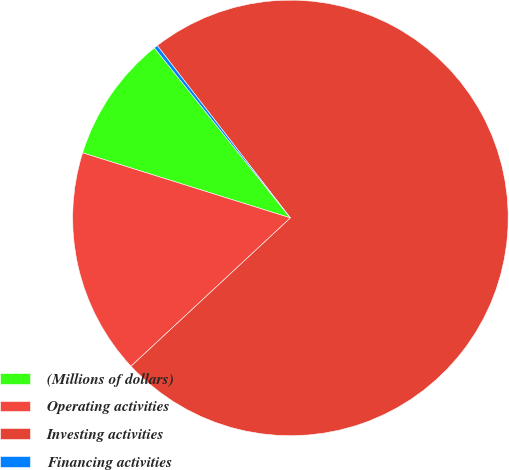<chart> <loc_0><loc_0><loc_500><loc_500><pie_chart><fcel>(Millions of dollars)<fcel>Operating activities<fcel>Investing activities<fcel>Financing activities<nl><fcel>9.43%<fcel>16.76%<fcel>73.54%<fcel>0.27%<nl></chart> 